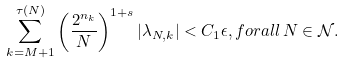Convert formula to latex. <formula><loc_0><loc_0><loc_500><loc_500>\sum _ { k = M + 1 } ^ { \tau ( N ) } \left ( \frac { 2 ^ { n _ { k } } } { N } \right ) ^ { 1 + s } | \lambda _ { N , k } | < C _ { 1 } \epsilon , f o r a l l \, N \in \mathcal { N } .</formula> 